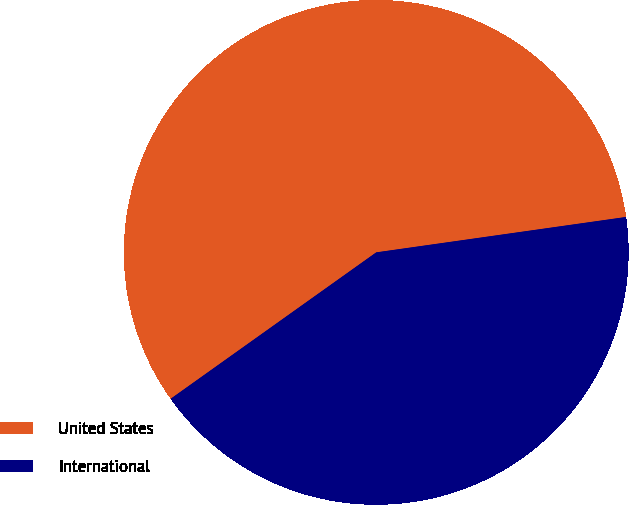Convert chart to OTSL. <chart><loc_0><loc_0><loc_500><loc_500><pie_chart><fcel>United States<fcel>International<nl><fcel>57.61%<fcel>42.39%<nl></chart> 